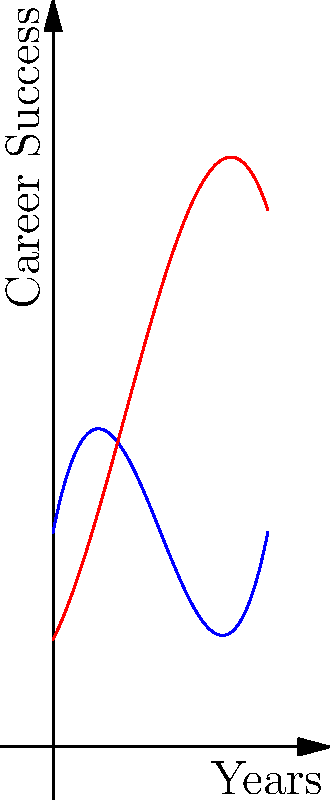The graph shows the career trajectories of jazz guitarists Wes Montgomery and Jim Hall over a 10-year period. At which year do their career success levels intersect for the second time, and what is the approximate success level at this intersection? To solve this problem, we need to follow these steps:

1. Observe the graph carefully. We can see that the blue line (Wes Montgomery) and the red line (Jim Hall) intersect twice.

2. The first intersection occurs early in their careers, around year 1-2.

3. The second intersection, which we're interested in, occurs later in their careers.

4. By tracing the lines, we can estimate that the second intersection occurs between year 7 and 8.

5. To get a more precise answer, we can look at where the lines cross. The intersection appears to be closest to year 7.5.

6. At this intersection point, we can estimate the career success level by looking at the y-axis. The point seems to be slightly above the midpoint between 20 and 25.

7. Therefore, we can approximate the career success level at the intersection to be about 23.
Answer: Year 7.5, Success level 23 